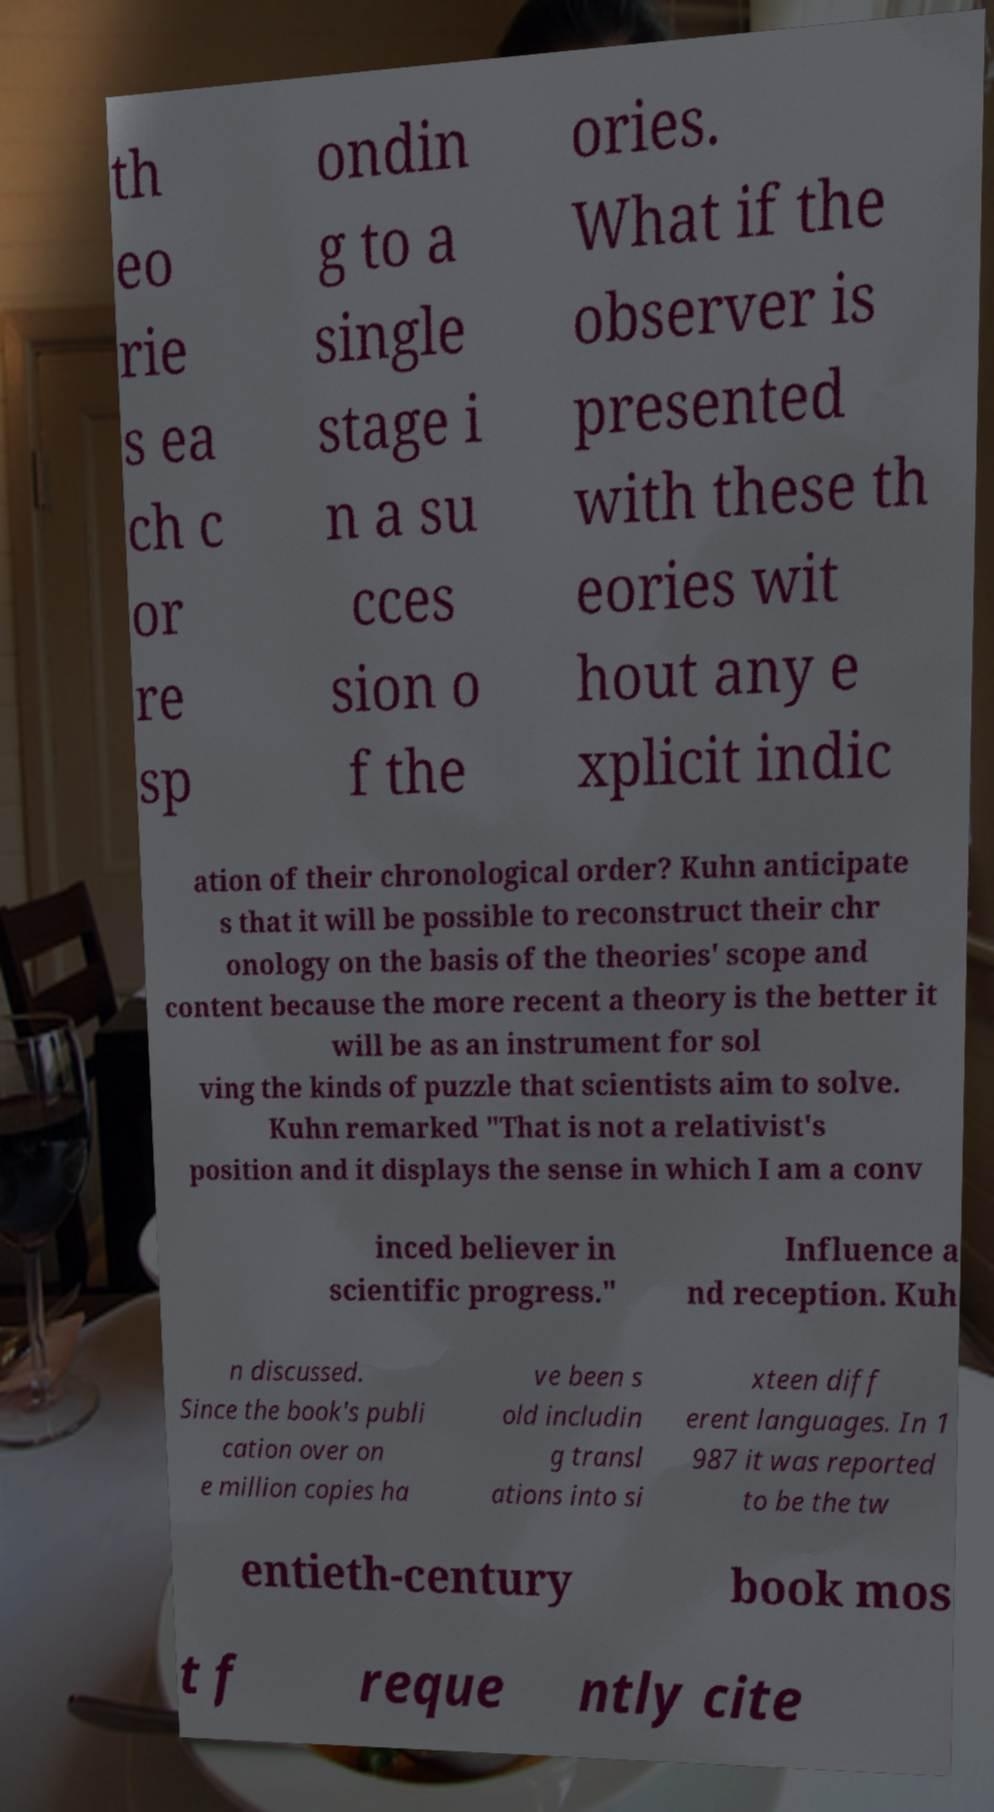For documentation purposes, I need the text within this image transcribed. Could you provide that? th eo rie s ea ch c or re sp ondin g to a single stage i n a su cces sion o f the ories. What if the observer is presented with these th eories wit hout any e xplicit indic ation of their chronological order? Kuhn anticipate s that it will be possible to reconstruct their chr onology on the basis of the theories' scope and content because the more recent a theory is the better it will be as an instrument for sol ving the kinds of puzzle that scientists aim to solve. Kuhn remarked "That is not a relativist's position and it displays the sense in which I am a conv inced believer in scientific progress." Influence a nd reception. Kuh n discussed. Since the book's publi cation over on e million copies ha ve been s old includin g transl ations into si xteen diff erent languages. In 1 987 it was reported to be the tw entieth-century book mos t f reque ntly cite 